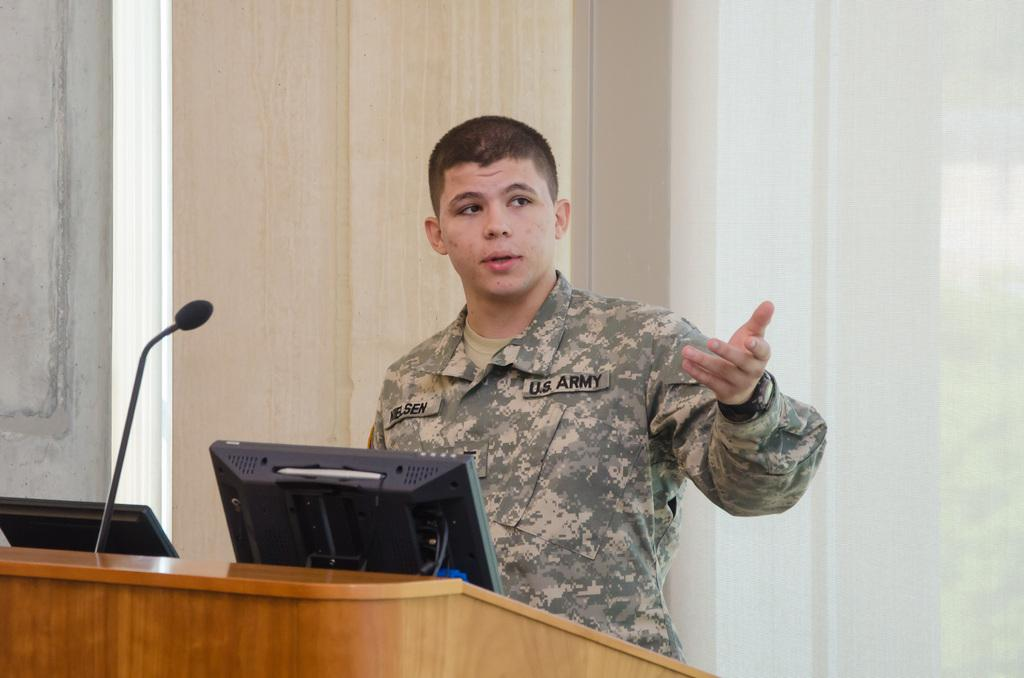What is the main subject of the image? There is a person standing in the image. What electronic devices can be seen in the image? There is a monitor and a laptop in the image. What object is used for amplifying sound in the image? There is a microphone in the image. What architectural feature is present in the image? There is a window and a wall in the image. What type of lumber is being used to construct the apparel in the image? There is no lumber or apparel present in the image. How can we tell if the person in the image is a beginner at using the microphone? The image does not provide any information about the person's experience level with the microphone. 